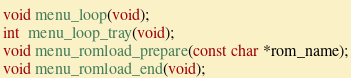<code> <loc_0><loc_0><loc_500><loc_500><_C_>
void menu_loop(void);
int  menu_loop_tray(void);
void menu_romload_prepare(const char *rom_name);
void menu_romload_end(void);

</code> 